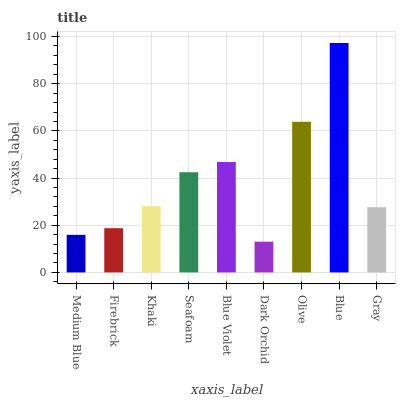Is Firebrick the minimum?
Answer yes or no. No. Is Firebrick the maximum?
Answer yes or no. No. Is Firebrick greater than Medium Blue?
Answer yes or no. Yes. Is Medium Blue less than Firebrick?
Answer yes or no. Yes. Is Medium Blue greater than Firebrick?
Answer yes or no. No. Is Firebrick less than Medium Blue?
Answer yes or no. No. Is Khaki the high median?
Answer yes or no. Yes. Is Khaki the low median?
Answer yes or no. Yes. Is Medium Blue the high median?
Answer yes or no. No. Is Blue the low median?
Answer yes or no. No. 